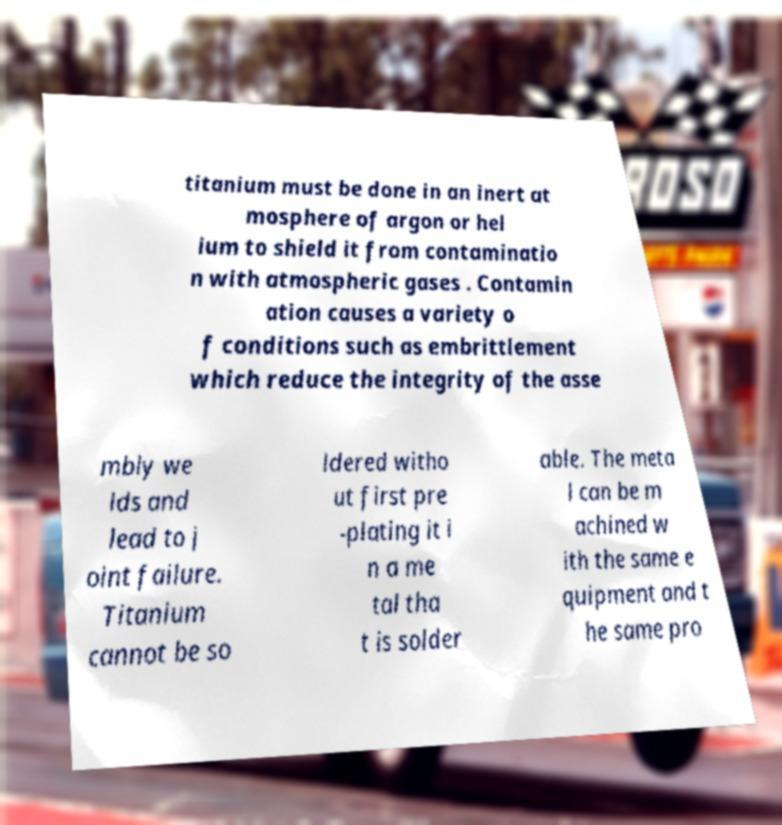I need the written content from this picture converted into text. Can you do that? titanium must be done in an inert at mosphere of argon or hel ium to shield it from contaminatio n with atmospheric gases . Contamin ation causes a variety o f conditions such as embrittlement which reduce the integrity of the asse mbly we lds and lead to j oint failure. Titanium cannot be so ldered witho ut first pre -plating it i n a me tal tha t is solder able. The meta l can be m achined w ith the same e quipment and t he same pro 